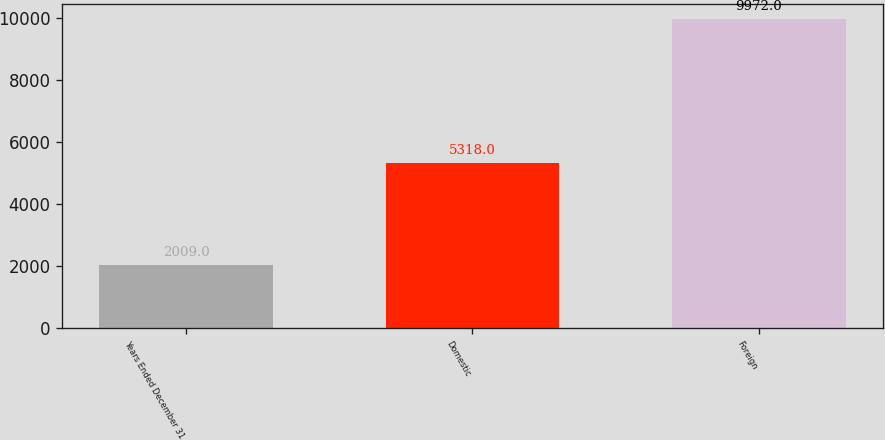Convert chart to OTSL. <chart><loc_0><loc_0><loc_500><loc_500><bar_chart><fcel>Years Ended December 31<fcel>Domestic<fcel>Foreign<nl><fcel>2009<fcel>5318<fcel>9972<nl></chart> 